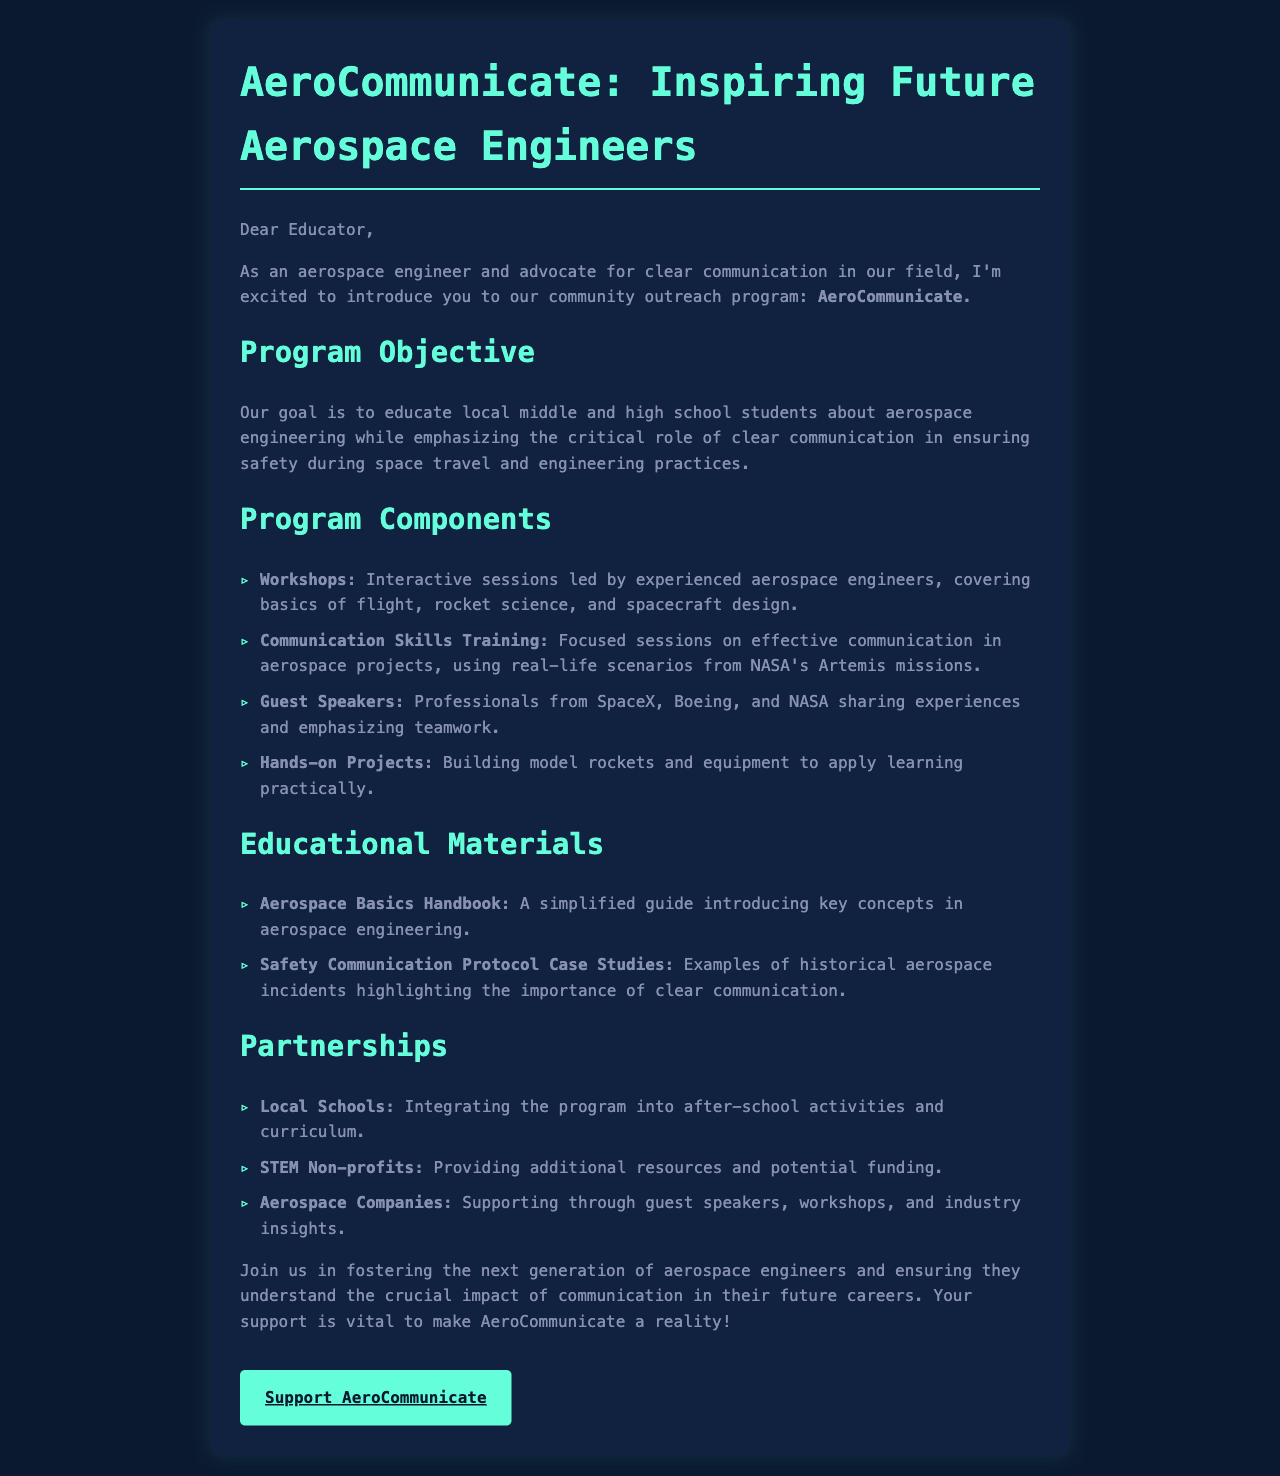What is the name of the outreach program? The outreach program is explicitly named AeroCommunicate in the document.
Answer: AeroCommunicate What age group does the program target? The program is aimed at middle and high school students, as stated in the objective.
Answer: Middle and high school students What are the interactive sessions led by experienced aerospace engineers called? These sessions are referred to as Workshops in the program components.
Answer: Workshops Which aerospace company is mentioned as sharing experiences with students? SpaceX is one of the companies mentioned that will have professionals share experiences.
Answer: SpaceX What type of handbook will be provided to students? The document specifies that an Aerospace Basics Handbook will be provided as educational material.
Answer: Aerospace Basics Handbook Why is clear communication emphasized in the program? Clear communication is essential for ensuring safety during space travel and engineering practices.
Answer: Safety during space travel How many main program components are listed? The document lists four main program components under the Program Components section.
Answer: Four What type of materials are case studies categorized under? The case studies are categorized under Safety Communication Protocol in the Educational Materials section.
Answer: Safety Communication Protocol What color is used for the title text in the document? The color used for the title text is explicitly noted as #64ffda in the style section.
Answer: #64ffda 